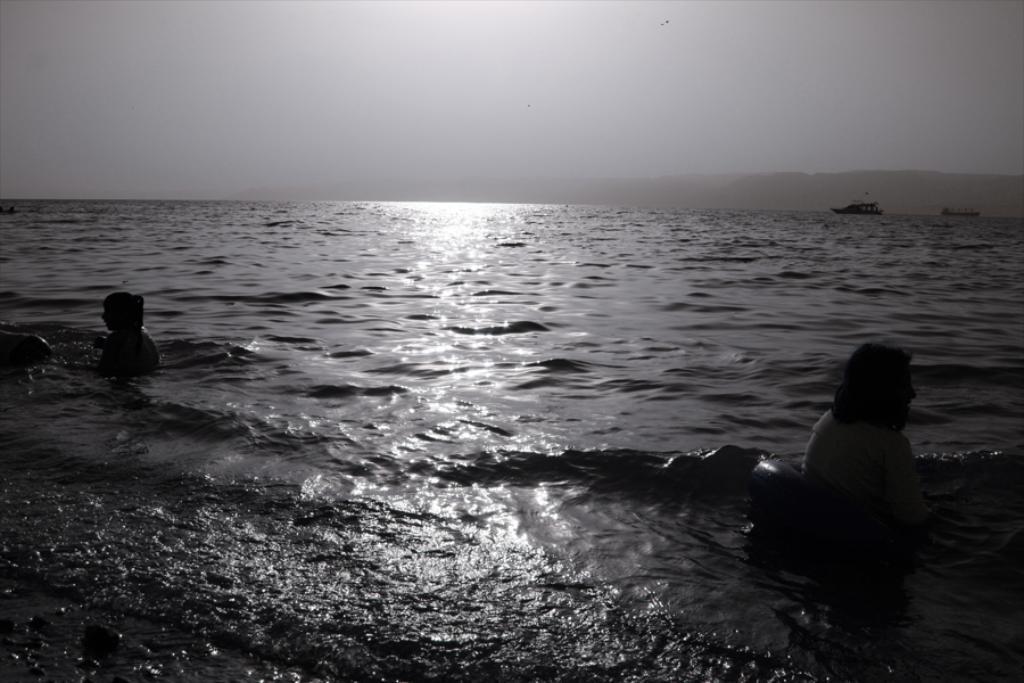Describe this image in one or two sentences. In this image we can see two people are swimming in the water. In the background, we can see ships floating on the water, hills and the sky. 